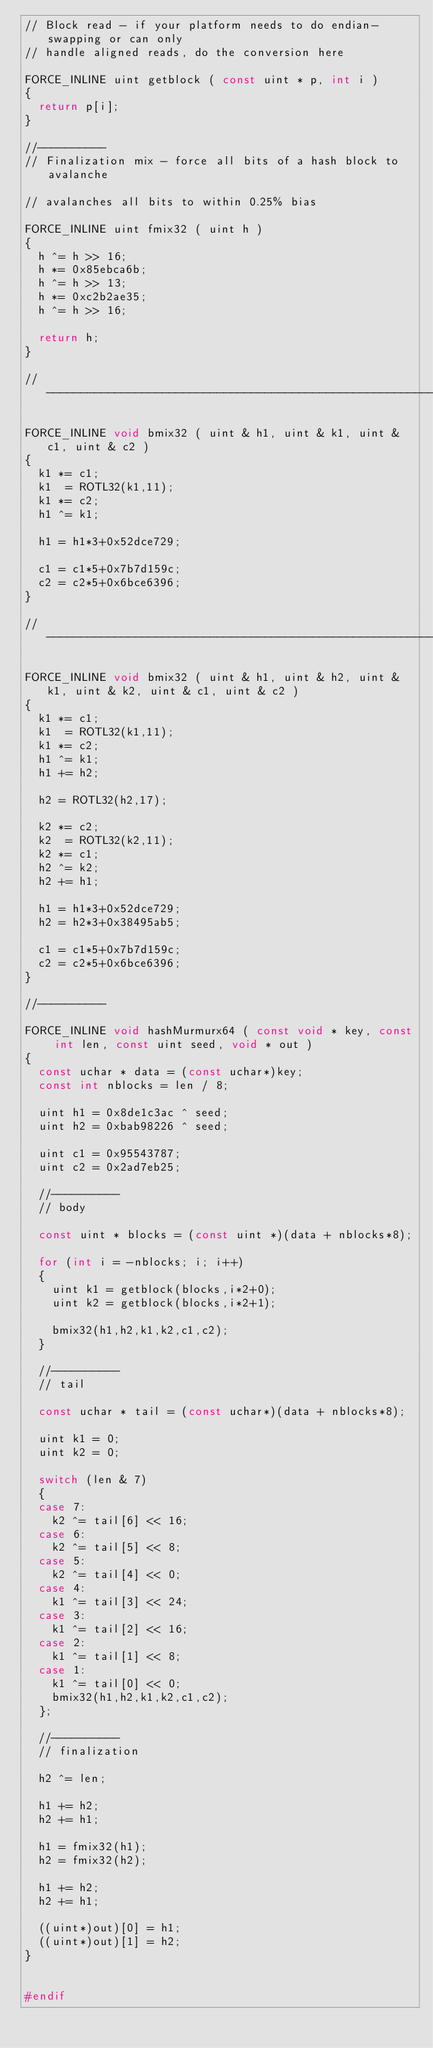<code> <loc_0><loc_0><loc_500><loc_500><_C++_>// Block read - if your platform needs to do endian-swapping or can only
// handle aligned reads, do the conversion here

FORCE_INLINE uint getblock ( const uint * p, int i )
{
  return p[i];
}

//----------
// Finalization mix - force all bits of a hash block to avalanche

// avalanches all bits to within 0.25% bias

FORCE_INLINE uint fmix32 ( uint h )
{
  h ^= h >> 16;
  h *= 0x85ebca6b;
  h ^= h >> 13;
  h *= 0xc2b2ae35;
  h ^= h >> 16;

  return h;
}

//-----------------------------------------------------------------------------

FORCE_INLINE void bmix32 ( uint & h1, uint & k1, uint & c1, uint & c2 )
{
  k1 *= c1;
  k1  = ROTL32(k1,11);
  k1 *= c2;
  h1 ^= k1;

  h1 = h1*3+0x52dce729;

  c1 = c1*5+0x7b7d159c;
  c2 = c2*5+0x6bce6396;
}

//-----------------------------------------------------------------------------

FORCE_INLINE void bmix32 ( uint & h1, uint & h2, uint & k1, uint & k2, uint & c1, uint & c2 )
{
  k1 *= c1;
  k1  = ROTL32(k1,11);
  k1 *= c2;
  h1 ^= k1;
  h1 += h2;

  h2 = ROTL32(h2,17);

  k2 *= c2;
  k2  = ROTL32(k2,11);
  k2 *= c1;
  h2 ^= k2;
  h2 += h1;

  h1 = h1*3+0x52dce729;
  h2 = h2*3+0x38495ab5;

  c1 = c1*5+0x7b7d159c;
  c2 = c2*5+0x6bce6396;
}

//----------

FORCE_INLINE void hashMurmurx64 ( const void * key, const int len, const uint seed, void * out )
{
  const uchar * data = (const uchar*)key;
  const int nblocks = len / 8;

  uint h1 = 0x8de1c3ac ^ seed;
  uint h2 = 0xbab98226 ^ seed;

  uint c1 = 0x95543787;
  uint c2 = 0x2ad7eb25;

  //----------
  // body

  const uint * blocks = (const uint *)(data + nblocks*8);

  for (int i = -nblocks; i; i++)
  {
    uint k1 = getblock(blocks,i*2+0);
    uint k2 = getblock(blocks,i*2+1);

    bmix32(h1,h2,k1,k2,c1,c2);
  }

  //----------
  // tail

  const uchar * tail = (const uchar*)(data + nblocks*8);

  uint k1 = 0;
  uint k2 = 0;

  switch (len & 7)
  {
  case 7:
    k2 ^= tail[6] << 16;
  case 6:
    k2 ^= tail[5] << 8;
  case 5:
    k2 ^= tail[4] << 0;
  case 4:
    k1 ^= tail[3] << 24;
  case 3:
    k1 ^= tail[2] << 16;
  case 2:
    k1 ^= tail[1] << 8;
  case 1:
    k1 ^= tail[0] << 0;
    bmix32(h1,h2,k1,k2,c1,c2);
  };

  //----------
  // finalization

  h2 ^= len;

  h1 += h2;
  h2 += h1;

  h1 = fmix32(h1);
  h2 = fmix32(h2);

  h1 += h2;
  h2 += h1;

  ((uint*)out)[0] = h1;
  ((uint*)out)[1] = h2;
}


#endif
</code> 